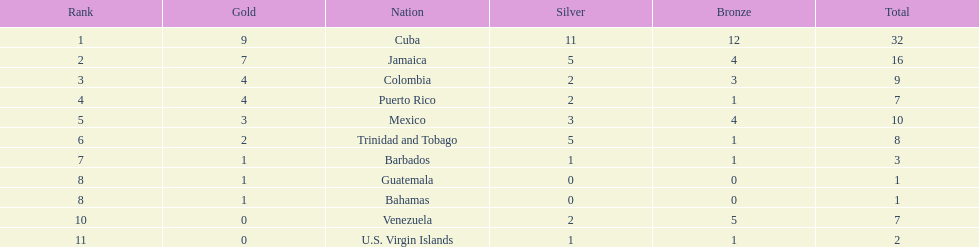What is the difference in medals between cuba and mexico? 22. 